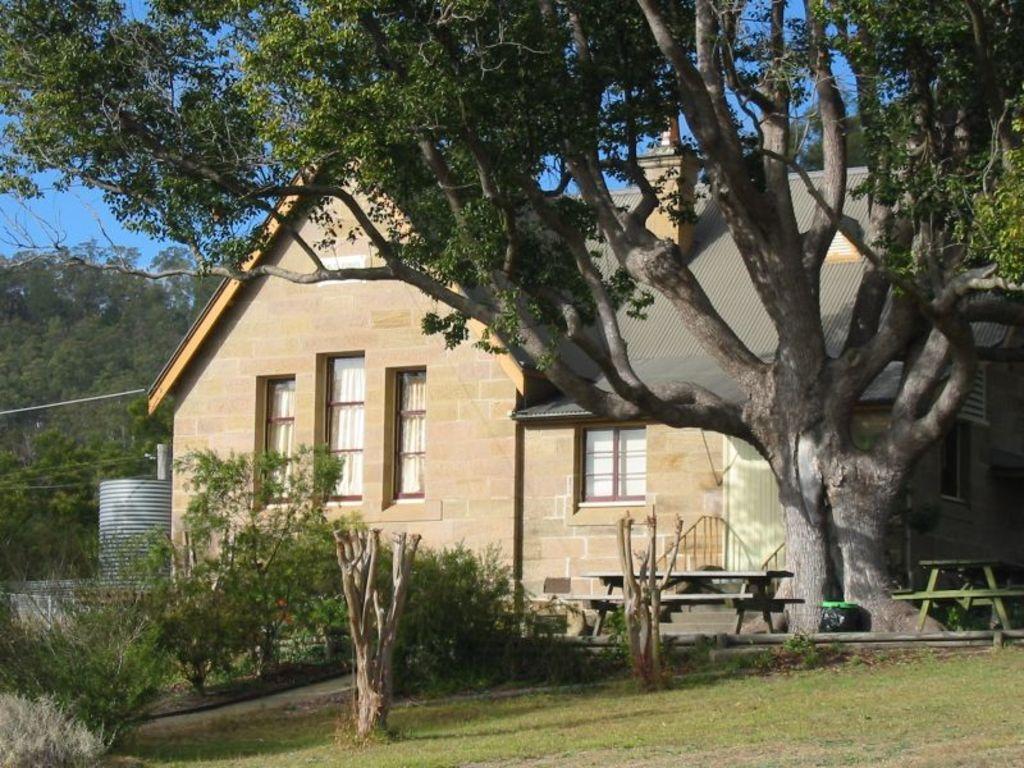Describe this image in one or two sentences. In this image, we can see a house. We can see the ground covered with grass, plants and trees. We can also see some benches, trunks of trees and a container. We can also see the sky. 